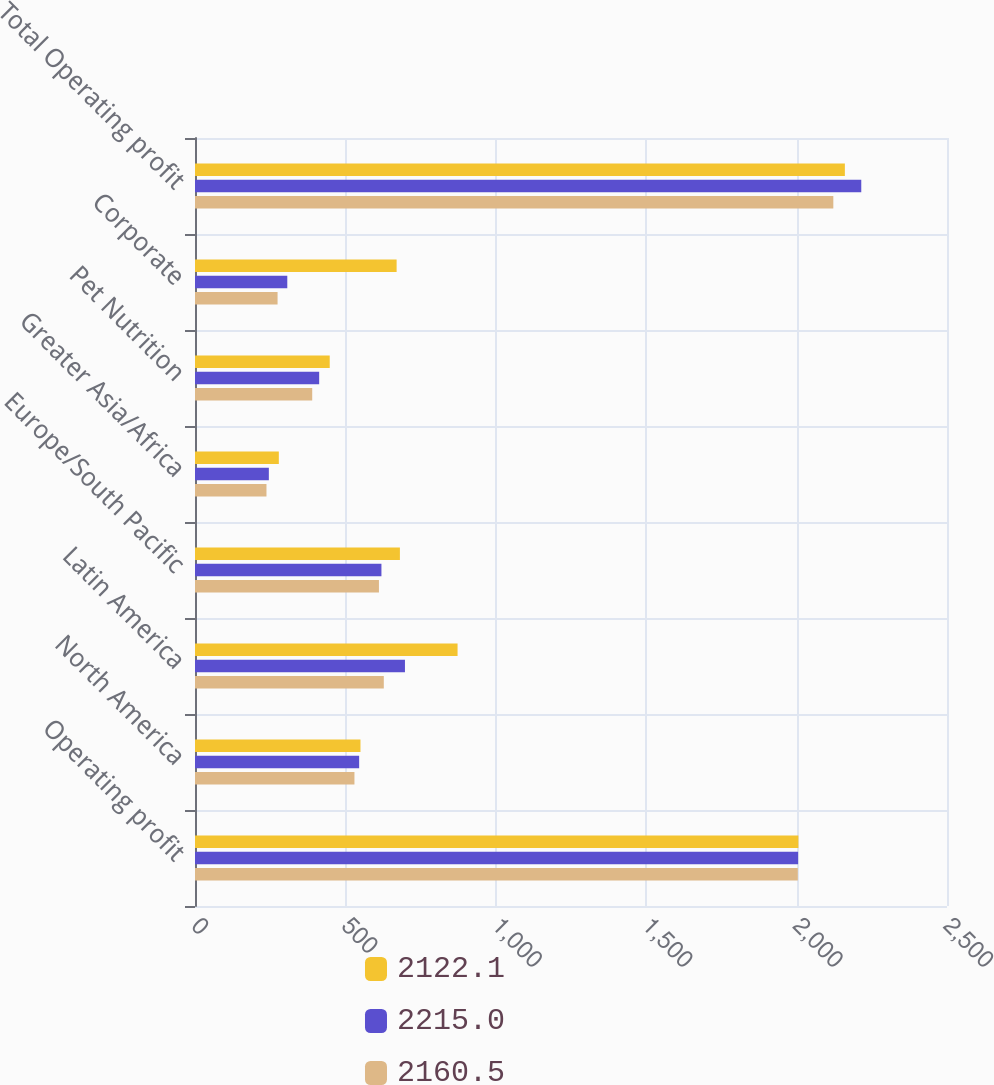Convert chart to OTSL. <chart><loc_0><loc_0><loc_500><loc_500><stacked_bar_chart><ecel><fcel>Operating profit<fcel>North America<fcel>Latin America<fcel>Europe/South Pacific<fcel>Greater Asia/Africa<fcel>Pet Nutrition<fcel>Corporate<fcel>Total Operating profit<nl><fcel>2122.1<fcel>2006<fcel>550.1<fcel>872.9<fcel>681.2<fcel>278.7<fcel>447.9<fcel>670.3<fcel>2160.5<nl><fcel>2215<fcel>2005<fcel>545.7<fcel>698<fcel>619.8<fcel>245.5<fcel>412.8<fcel>306.8<fcel>2215<nl><fcel>2160.5<fcel>2004<fcel>530.1<fcel>627.7<fcel>611.5<fcel>237.6<fcel>389.7<fcel>274.5<fcel>2122.1<nl></chart> 